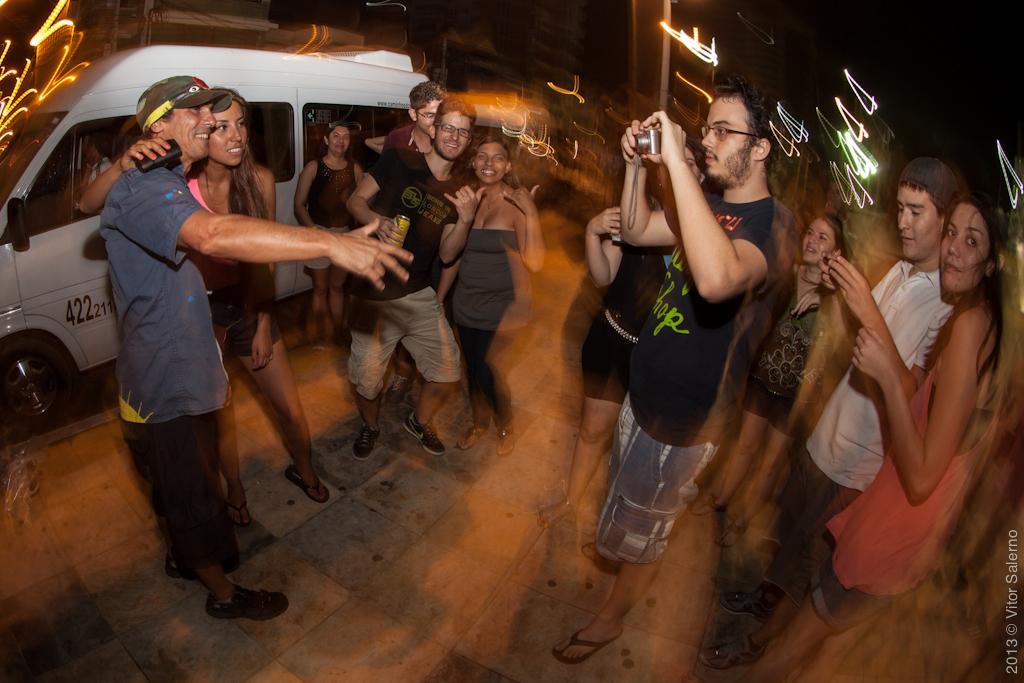What is happening in the image? There are people standing in the image. Can you describe what one of the people is doing? A man is holding a camera in the image. What can be seen on the left side of the image? There is a van on the left side of the image. How would you describe the background of the image? The background of the image appears blurry. How many babies are visible in the image? There are no babies present in the image. What type of flag is being waved by the people in the image? There is no flag visible in the image. 